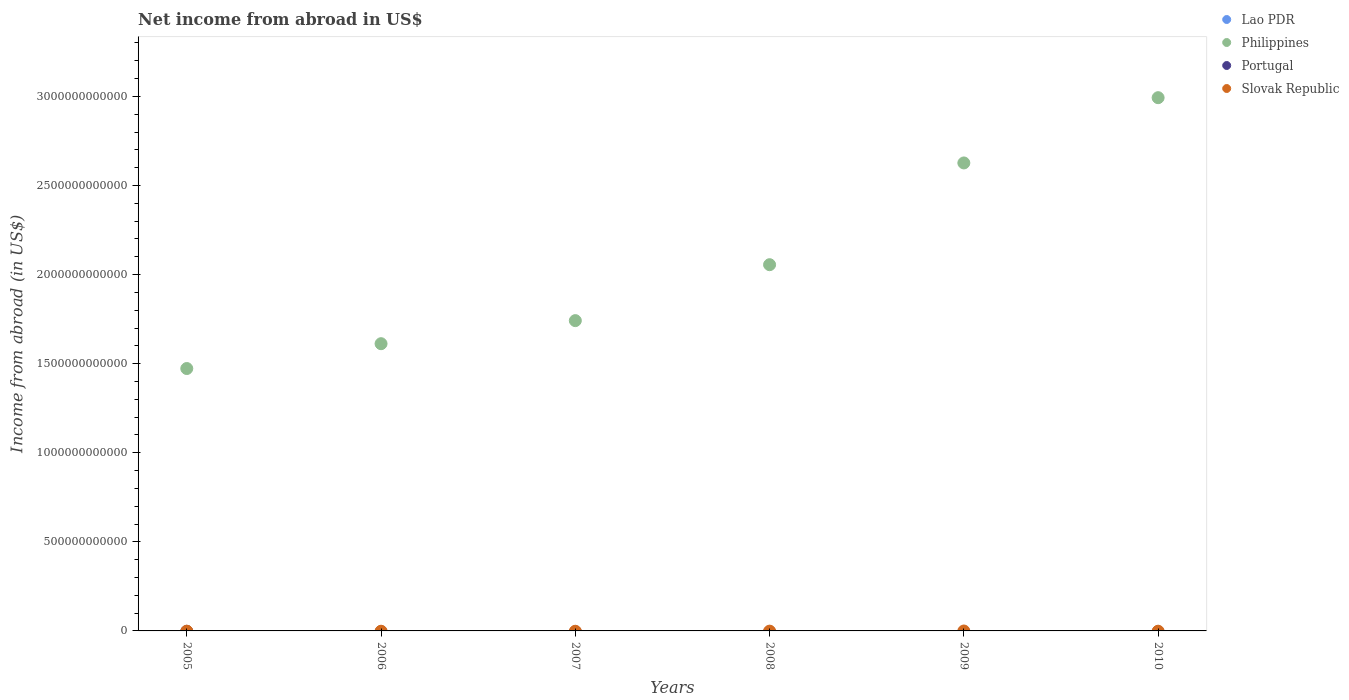How many different coloured dotlines are there?
Your response must be concise. 1. Across all years, what is the maximum net income from abroad in Philippines?
Give a very brief answer. 2.99e+12. Across all years, what is the minimum net income from abroad in Philippines?
Your answer should be very brief. 1.47e+12. In which year was the net income from abroad in Philippines maximum?
Offer a very short reply. 2010. What is the total net income from abroad in Slovak Republic in the graph?
Offer a terse response. 0. What is the difference between the net income from abroad in Philippines in 2009 and that in 2010?
Ensure brevity in your answer.  -3.66e+11. What is the difference between the net income from abroad in Lao PDR in 2006 and the net income from abroad in Slovak Republic in 2007?
Provide a short and direct response. 0. What is the average net income from abroad in Philippines per year?
Offer a terse response. 2.08e+12. What is the ratio of the net income from abroad in Philippines in 2008 to that in 2010?
Your response must be concise. 0.69. Is the net income from abroad in Philippines in 2006 less than that in 2010?
Give a very brief answer. Yes. What is the difference between the highest and the second highest net income from abroad in Philippines?
Offer a very short reply. 3.66e+11. What is the difference between the highest and the lowest net income from abroad in Philippines?
Your response must be concise. 1.52e+12. Is it the case that in every year, the sum of the net income from abroad in Philippines and net income from abroad in Portugal  is greater than the sum of net income from abroad in Slovak Republic and net income from abroad in Lao PDR?
Your response must be concise. Yes. Is it the case that in every year, the sum of the net income from abroad in Slovak Republic and net income from abroad in Philippines  is greater than the net income from abroad in Lao PDR?
Offer a very short reply. Yes. Does the net income from abroad in Portugal monotonically increase over the years?
Provide a short and direct response. No. What is the difference between two consecutive major ticks on the Y-axis?
Make the answer very short. 5.00e+11. Does the graph contain any zero values?
Provide a succinct answer. Yes. What is the title of the graph?
Give a very brief answer. Net income from abroad in US$. What is the label or title of the X-axis?
Provide a succinct answer. Years. What is the label or title of the Y-axis?
Your answer should be very brief. Income from abroad (in US$). What is the Income from abroad (in US$) of Lao PDR in 2005?
Your answer should be compact. 0. What is the Income from abroad (in US$) in Philippines in 2005?
Offer a very short reply. 1.47e+12. What is the Income from abroad (in US$) in Portugal in 2005?
Make the answer very short. 0. What is the Income from abroad (in US$) in Slovak Republic in 2005?
Keep it short and to the point. 0. What is the Income from abroad (in US$) of Philippines in 2006?
Give a very brief answer. 1.61e+12. What is the Income from abroad (in US$) in Lao PDR in 2007?
Provide a short and direct response. 0. What is the Income from abroad (in US$) in Philippines in 2007?
Your answer should be compact. 1.74e+12. What is the Income from abroad (in US$) of Portugal in 2007?
Your answer should be compact. 0. What is the Income from abroad (in US$) of Lao PDR in 2008?
Your answer should be compact. 0. What is the Income from abroad (in US$) of Philippines in 2008?
Offer a very short reply. 2.06e+12. What is the Income from abroad (in US$) in Portugal in 2008?
Offer a terse response. 0. What is the Income from abroad (in US$) in Lao PDR in 2009?
Provide a succinct answer. 0. What is the Income from abroad (in US$) in Philippines in 2009?
Your answer should be very brief. 2.63e+12. What is the Income from abroad (in US$) of Lao PDR in 2010?
Your answer should be very brief. 0. What is the Income from abroad (in US$) of Philippines in 2010?
Provide a short and direct response. 2.99e+12. Across all years, what is the maximum Income from abroad (in US$) in Philippines?
Your answer should be compact. 2.99e+12. Across all years, what is the minimum Income from abroad (in US$) of Philippines?
Your answer should be compact. 1.47e+12. What is the total Income from abroad (in US$) in Lao PDR in the graph?
Provide a succinct answer. 0. What is the total Income from abroad (in US$) of Philippines in the graph?
Ensure brevity in your answer.  1.25e+13. What is the total Income from abroad (in US$) of Slovak Republic in the graph?
Your response must be concise. 0. What is the difference between the Income from abroad (in US$) of Philippines in 2005 and that in 2006?
Ensure brevity in your answer.  -1.39e+11. What is the difference between the Income from abroad (in US$) in Philippines in 2005 and that in 2007?
Your response must be concise. -2.69e+11. What is the difference between the Income from abroad (in US$) of Philippines in 2005 and that in 2008?
Your response must be concise. -5.83e+11. What is the difference between the Income from abroad (in US$) in Philippines in 2005 and that in 2009?
Provide a succinct answer. -1.15e+12. What is the difference between the Income from abroad (in US$) of Philippines in 2005 and that in 2010?
Offer a very short reply. -1.52e+12. What is the difference between the Income from abroad (in US$) of Philippines in 2006 and that in 2007?
Your answer should be very brief. -1.29e+11. What is the difference between the Income from abroad (in US$) in Philippines in 2006 and that in 2008?
Keep it short and to the point. -4.43e+11. What is the difference between the Income from abroad (in US$) of Philippines in 2006 and that in 2009?
Provide a succinct answer. -1.01e+12. What is the difference between the Income from abroad (in US$) in Philippines in 2006 and that in 2010?
Give a very brief answer. -1.38e+12. What is the difference between the Income from abroad (in US$) of Philippines in 2007 and that in 2008?
Offer a terse response. -3.14e+11. What is the difference between the Income from abroad (in US$) of Philippines in 2007 and that in 2009?
Provide a succinct answer. -8.85e+11. What is the difference between the Income from abroad (in US$) in Philippines in 2007 and that in 2010?
Your answer should be compact. -1.25e+12. What is the difference between the Income from abroad (in US$) of Philippines in 2008 and that in 2009?
Your response must be concise. -5.71e+11. What is the difference between the Income from abroad (in US$) of Philippines in 2008 and that in 2010?
Offer a terse response. -9.37e+11. What is the difference between the Income from abroad (in US$) of Philippines in 2009 and that in 2010?
Offer a terse response. -3.66e+11. What is the average Income from abroad (in US$) of Lao PDR per year?
Your answer should be very brief. 0. What is the average Income from abroad (in US$) of Philippines per year?
Keep it short and to the point. 2.08e+12. What is the average Income from abroad (in US$) in Portugal per year?
Offer a very short reply. 0. What is the average Income from abroad (in US$) of Slovak Republic per year?
Keep it short and to the point. 0. What is the ratio of the Income from abroad (in US$) in Philippines in 2005 to that in 2006?
Provide a short and direct response. 0.91. What is the ratio of the Income from abroad (in US$) in Philippines in 2005 to that in 2007?
Ensure brevity in your answer.  0.85. What is the ratio of the Income from abroad (in US$) of Philippines in 2005 to that in 2008?
Provide a succinct answer. 0.72. What is the ratio of the Income from abroad (in US$) of Philippines in 2005 to that in 2009?
Your answer should be very brief. 0.56. What is the ratio of the Income from abroad (in US$) in Philippines in 2005 to that in 2010?
Provide a short and direct response. 0.49. What is the ratio of the Income from abroad (in US$) of Philippines in 2006 to that in 2007?
Ensure brevity in your answer.  0.93. What is the ratio of the Income from abroad (in US$) in Philippines in 2006 to that in 2008?
Offer a terse response. 0.78. What is the ratio of the Income from abroad (in US$) in Philippines in 2006 to that in 2009?
Give a very brief answer. 0.61. What is the ratio of the Income from abroad (in US$) in Philippines in 2006 to that in 2010?
Provide a short and direct response. 0.54. What is the ratio of the Income from abroad (in US$) of Philippines in 2007 to that in 2008?
Offer a very short reply. 0.85. What is the ratio of the Income from abroad (in US$) in Philippines in 2007 to that in 2009?
Offer a terse response. 0.66. What is the ratio of the Income from abroad (in US$) of Philippines in 2007 to that in 2010?
Keep it short and to the point. 0.58. What is the ratio of the Income from abroad (in US$) of Philippines in 2008 to that in 2009?
Your response must be concise. 0.78. What is the ratio of the Income from abroad (in US$) of Philippines in 2008 to that in 2010?
Provide a short and direct response. 0.69. What is the ratio of the Income from abroad (in US$) in Philippines in 2009 to that in 2010?
Provide a short and direct response. 0.88. What is the difference between the highest and the second highest Income from abroad (in US$) in Philippines?
Offer a terse response. 3.66e+11. What is the difference between the highest and the lowest Income from abroad (in US$) in Philippines?
Make the answer very short. 1.52e+12. 